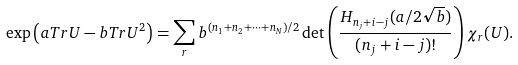Convert formula to latex. <formula><loc_0><loc_0><loc_500><loc_500>\exp \left ( a T r U - b T r U ^ { 2 } \right ) = \sum _ { r } b ^ { ( n _ { 1 } + n _ { 2 } + \cdots + n _ { N } ) / 2 } \det \left ( \frac { H _ { n _ { j } + i - j } ( a / 2 \sqrt { b } ) } { ( n _ { j } + i - j ) ! } \right ) \chi _ { r } ( U ) .</formula> 